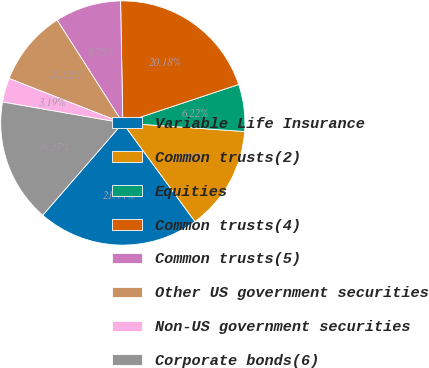Convert chart. <chart><loc_0><loc_0><loc_500><loc_500><pie_chart><fcel>Variable Life Insurance<fcel>Common trusts(2)<fcel>Equities<fcel>Common trusts(4)<fcel>Common trusts(5)<fcel>Other US government securities<fcel>Non-US government securities<fcel>Corporate bonds(6)<nl><fcel>21.44%<fcel>13.83%<fcel>6.22%<fcel>20.18%<fcel>8.75%<fcel>10.02%<fcel>3.19%<fcel>16.37%<nl></chart> 